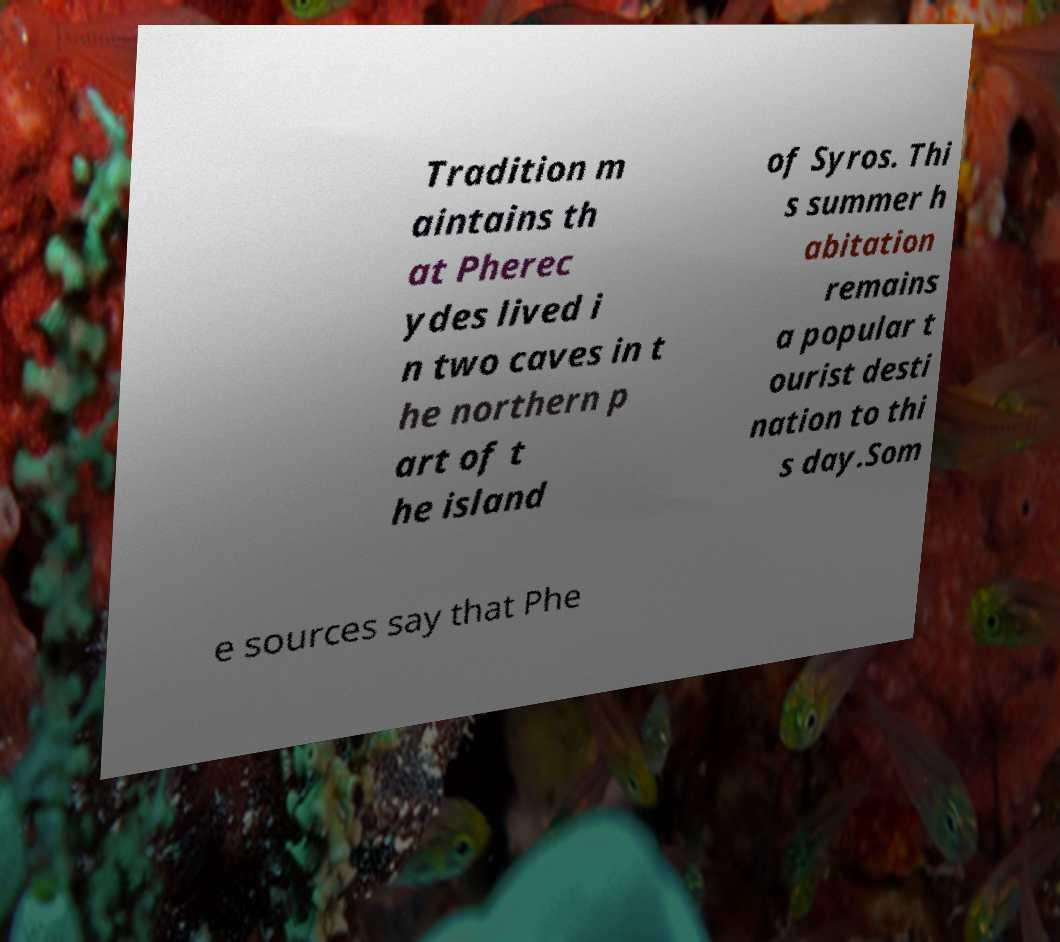Can you accurately transcribe the text from the provided image for me? Tradition m aintains th at Pherec ydes lived i n two caves in t he northern p art of t he island of Syros. Thi s summer h abitation remains a popular t ourist desti nation to thi s day.Som e sources say that Phe 